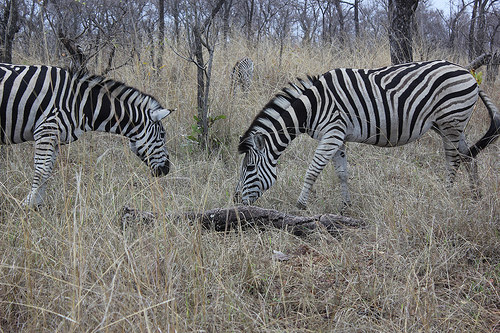What would the zebras in the image typically eat? Zebras typically feed on a variety of grasses found in their savanna habitat. They are grazing animals and their diet consists mostly of the tough grasses that are able to survive in the arid conditions shown in the image. 